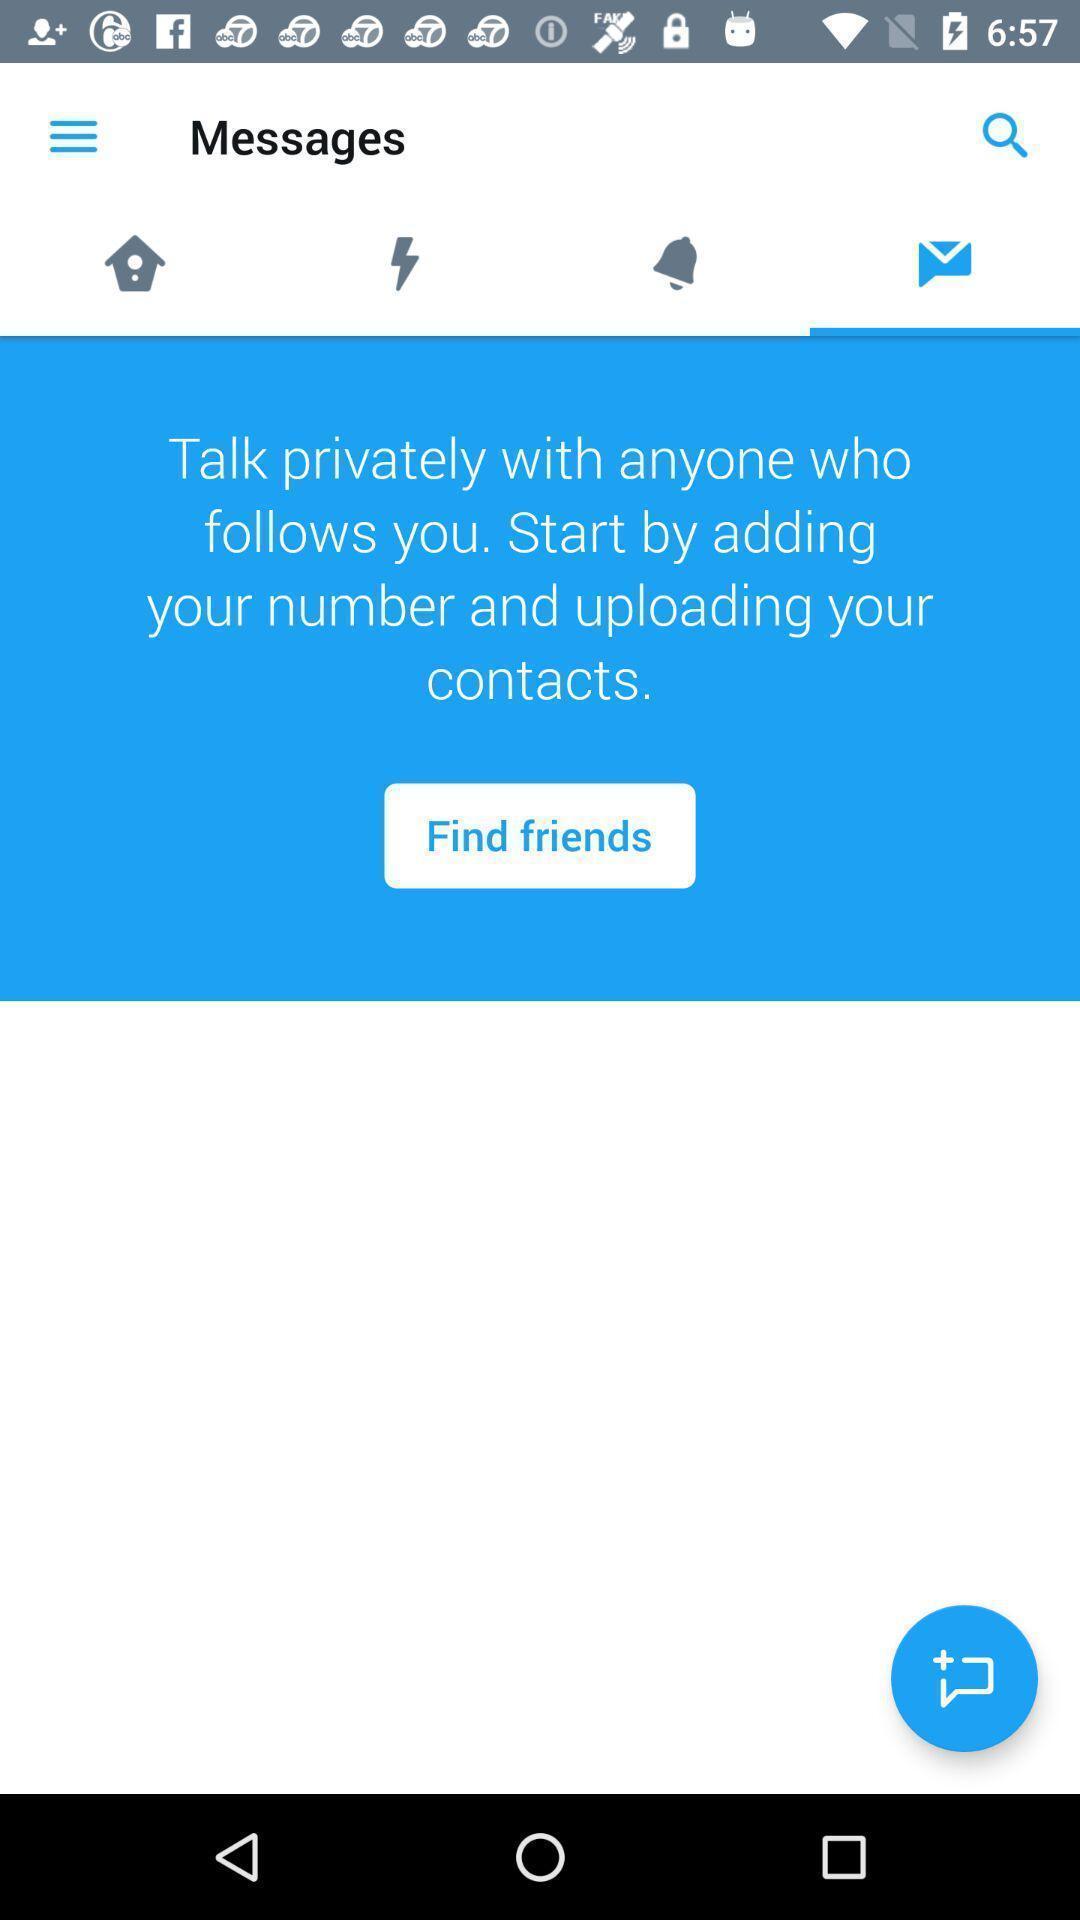Provide a textual representation of this image. Page with messages on a social app. 